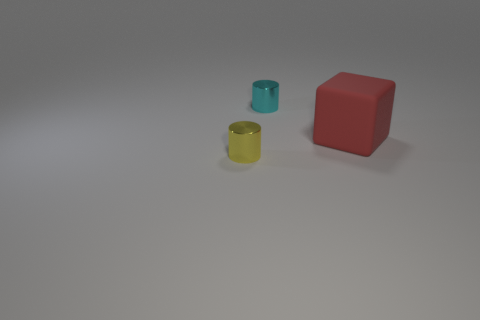Is there anything else that is the same size as the block?
Your response must be concise. No. Are there any tiny cylinders of the same color as the big rubber object?
Provide a succinct answer. No. There is a yellow object that is the same material as the small cyan thing; what is its size?
Make the answer very short. Small. What is the shape of the tiny metal object left of the small metal object behind the metal thing left of the tiny cyan metallic thing?
Provide a short and direct response. Cylinder. There is a object that is both to the left of the matte cube and to the right of the yellow metallic cylinder; what size is it?
Provide a short and direct response. Small. The rubber block is what color?
Offer a terse response. Red. What size is the cylinder that is behind the yellow cylinder?
Offer a terse response. Small. There is a metal cylinder that is right of the small shiny thing in front of the large rubber block; what number of tiny cylinders are in front of it?
Make the answer very short. 1. There is a small cylinder to the left of the small thing on the right side of the small yellow metallic cylinder; what color is it?
Offer a very short reply. Yellow. Is there another metal thing that has the same size as the cyan metallic thing?
Your answer should be compact. Yes. 